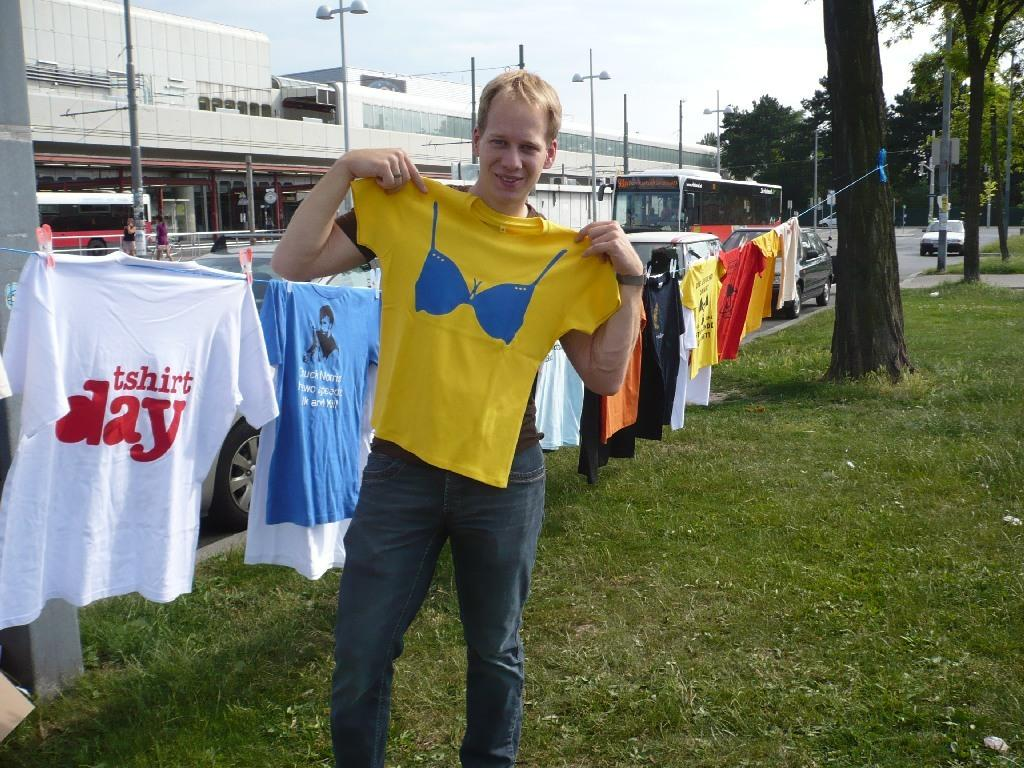<image>
Give a short and clear explanation of the subsequent image. A white shirt that says tshirt day hanging on a line 